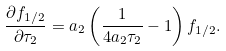<formula> <loc_0><loc_0><loc_500><loc_500>\frac { \partial f _ { 1 / 2 } } { \partial \tau _ { 2 } } = a _ { 2 } \left ( \frac { 1 } { 4 a _ { 2 } \tau _ { 2 } } - 1 \right ) f _ { 1 / 2 } .</formula> 